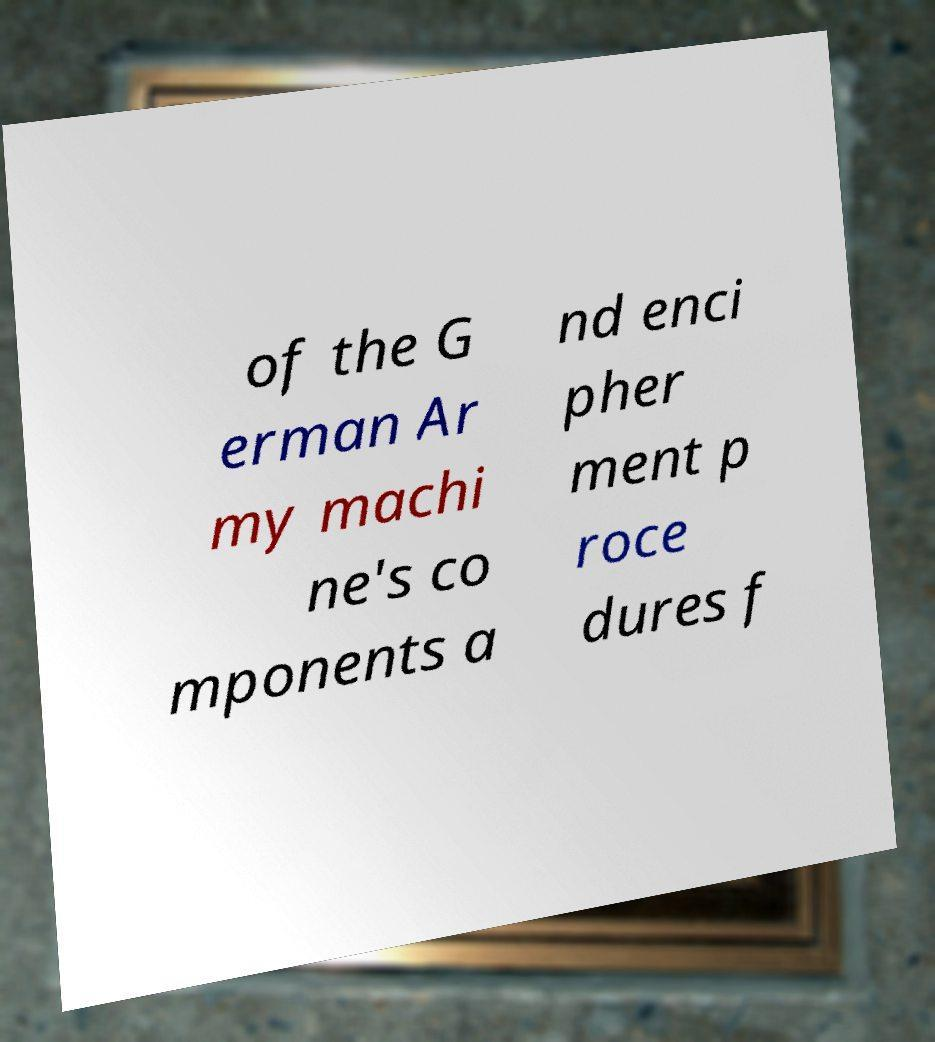Could you assist in decoding the text presented in this image and type it out clearly? of the G erman Ar my machi ne's co mponents a nd enci pher ment p roce dures f 